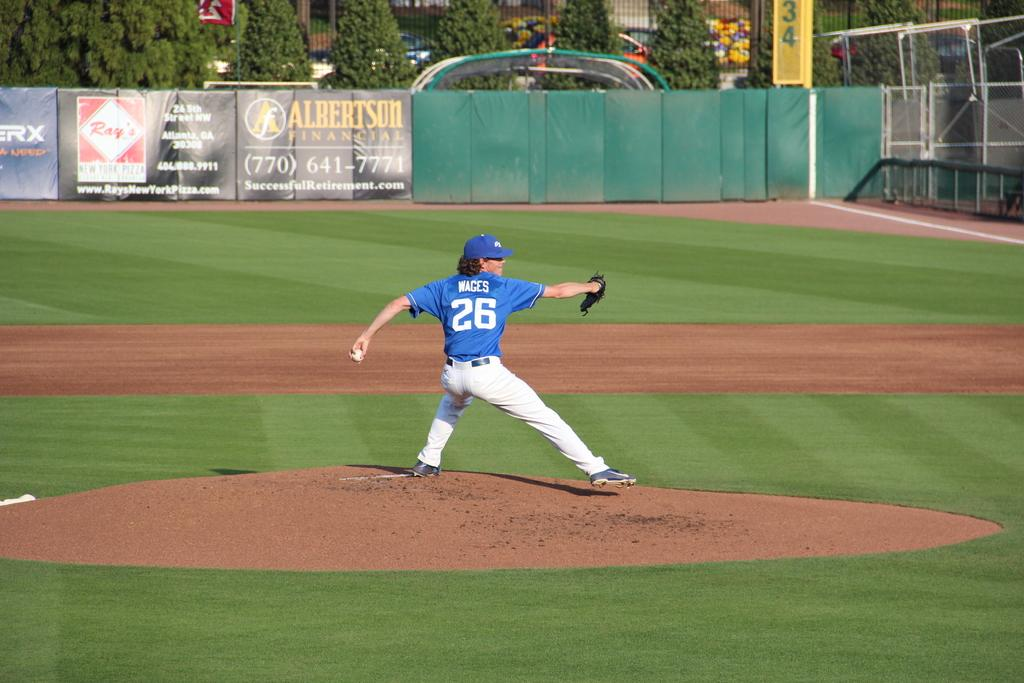<image>
Give a short and clear explanation of the subsequent image. An advertisement for Albertson Financial on the right field wall. 